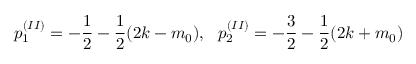<formula> <loc_0><loc_0><loc_500><loc_500>p _ { 1 } ^ { ( I I ) } = - \frac { 1 } { 2 } - \frac { 1 } { 2 } ( 2 k - m _ { 0 } ) , p _ { 2 } ^ { ( I I ) } = - \frac { 3 } { 2 } - \frac { 1 } { 2 } ( 2 k + m _ { 0 } )</formula> 